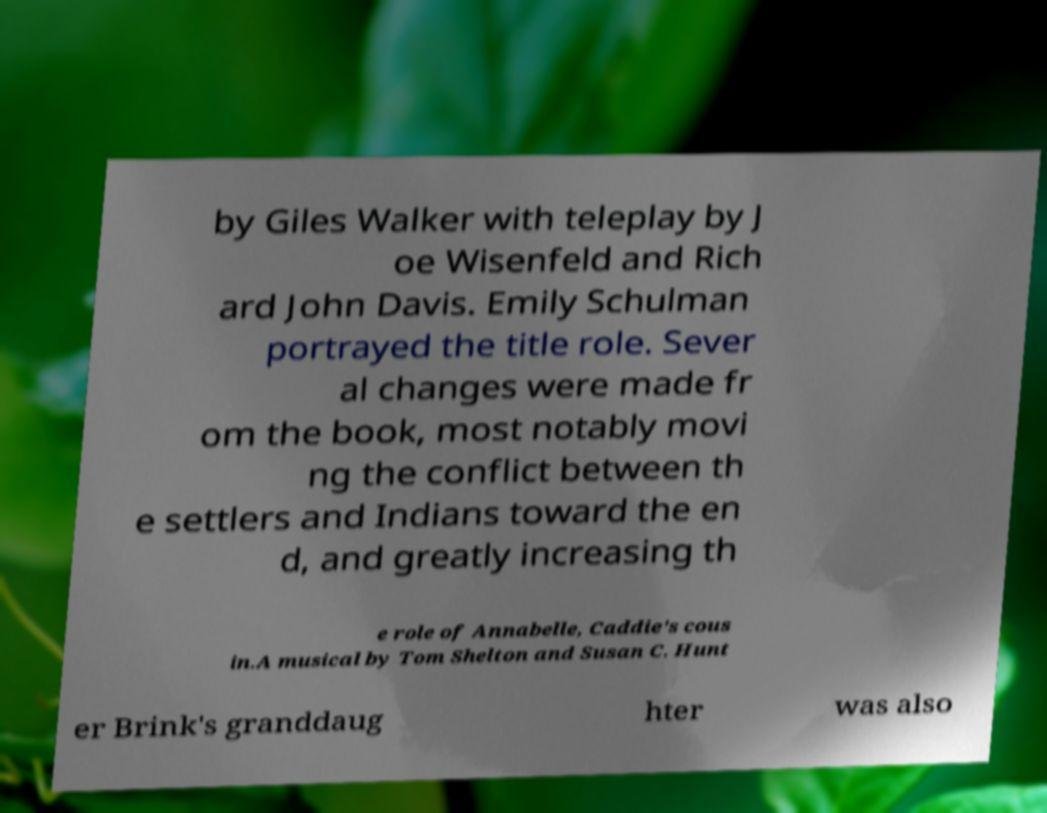Please read and relay the text visible in this image. What does it say? by Giles Walker with teleplay by J oe Wisenfeld and Rich ard John Davis. Emily Schulman portrayed the title role. Sever al changes were made fr om the book, most notably movi ng the conflict between th e settlers and Indians toward the en d, and greatly increasing th e role of Annabelle, Caddie's cous in.A musical by Tom Shelton and Susan C. Hunt er Brink's granddaug hter was also 